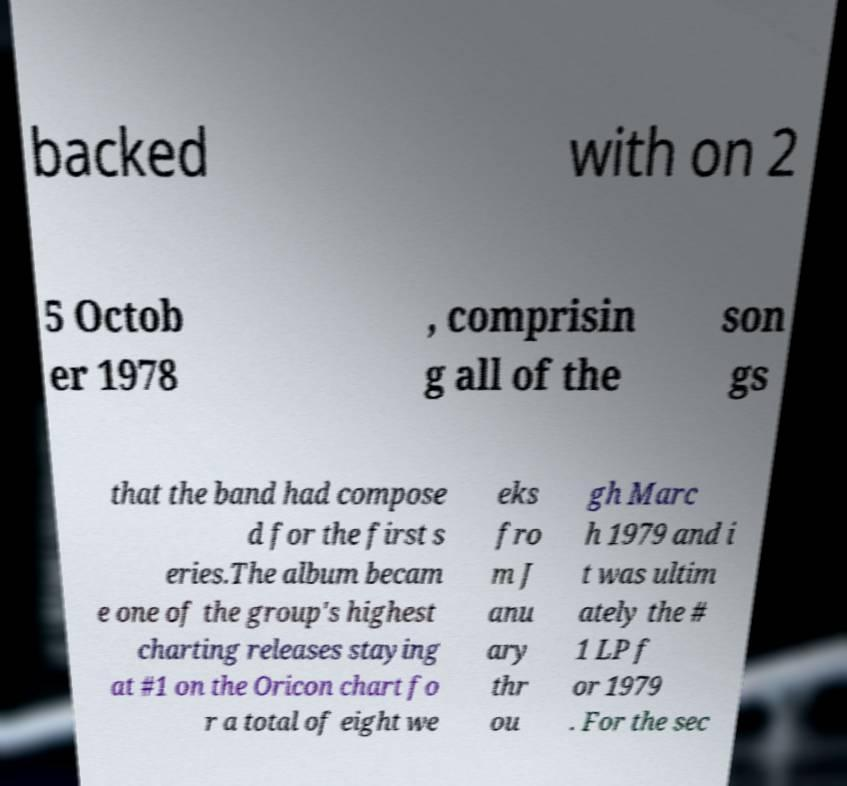I need the written content from this picture converted into text. Can you do that? backed with on 2 5 Octob er 1978 , comprisin g all of the son gs that the band had compose d for the first s eries.The album becam e one of the group's highest charting releases staying at #1 on the Oricon chart fo r a total of eight we eks fro m J anu ary thr ou gh Marc h 1979 and i t was ultim ately the # 1 LP f or 1979 . For the sec 